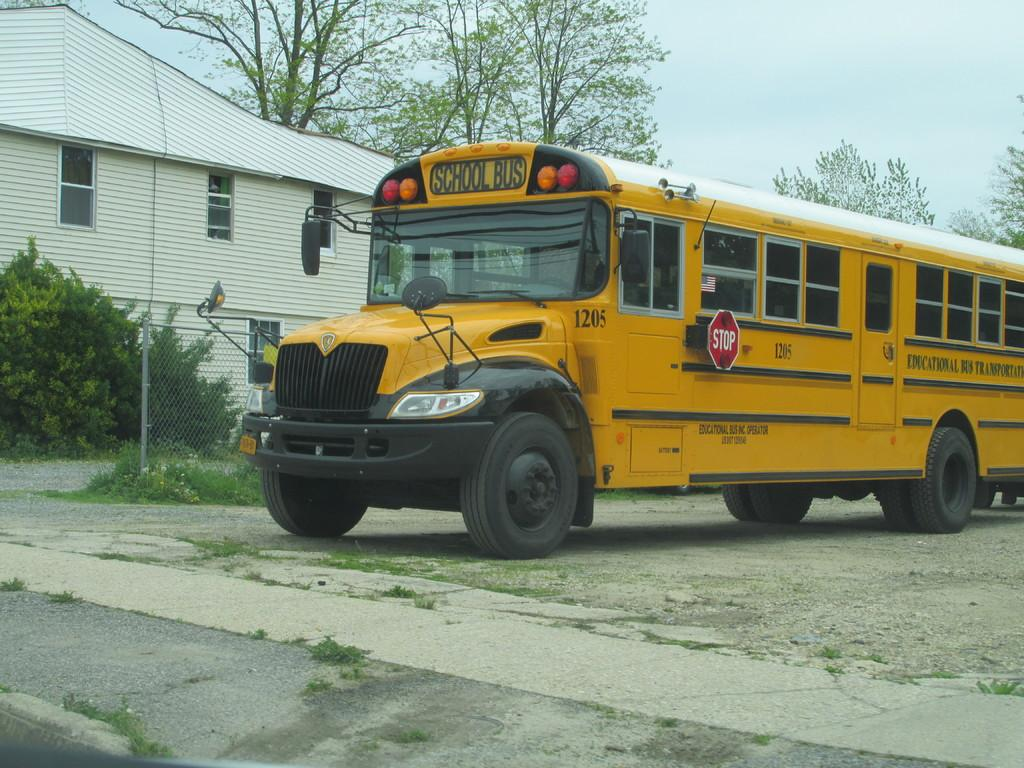What is the main subject in the foreground of the image? There is a bus in the foreground of the image. What is the position of the bus in relation to the ground? The bus is on the ground. What can be seen behind the bus? Fencing, grass, plants, and trees can be seen behind the bus. What is visible in the background of the image? There is a building and the sky visible in the background of the image. What type of knowledge is being shared between the plants in the image? There is no indication in the image that the plants are sharing knowledge or any other form of communication. 